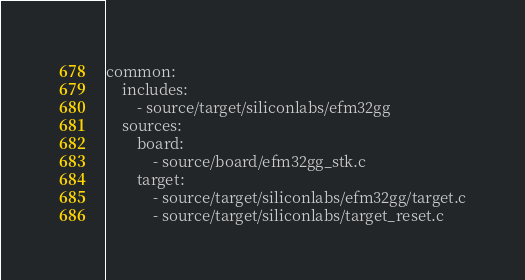<code> <loc_0><loc_0><loc_500><loc_500><_YAML_>common:
    includes:
        - source/target/siliconlabs/efm32gg
    sources:
        board:
            - source/board/efm32gg_stk.c
        target:
            - source/target/siliconlabs/efm32gg/target.c
            - source/target/siliconlabs/target_reset.c
</code> 